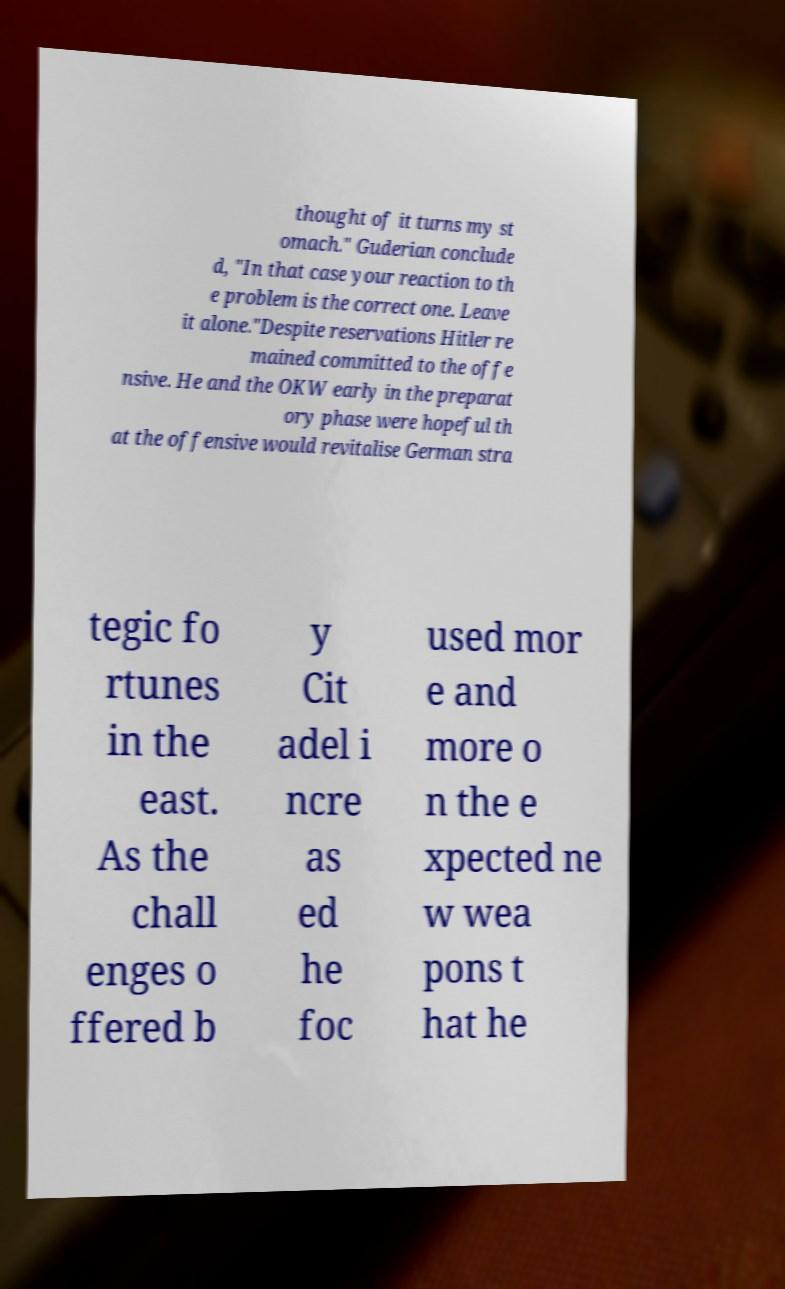I need the written content from this picture converted into text. Can you do that? thought of it turns my st omach." Guderian conclude d, "In that case your reaction to th e problem is the correct one. Leave it alone."Despite reservations Hitler re mained committed to the offe nsive. He and the OKW early in the preparat ory phase were hopeful th at the offensive would revitalise German stra tegic fo rtunes in the east. As the chall enges o ffered b y Cit adel i ncre as ed he foc used mor e and more o n the e xpected ne w wea pons t hat he 